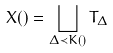<formula> <loc_0><loc_0><loc_500><loc_500>X ( ) = \bigsqcup _ { \Delta \prec K ( ) } T _ { \Delta }</formula> 